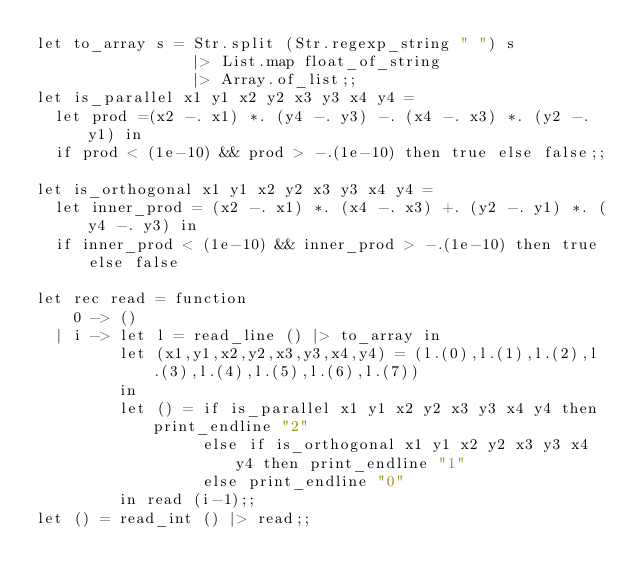Convert code to text. <code><loc_0><loc_0><loc_500><loc_500><_OCaml_>let to_array s = Str.split (Str.regexp_string " ") s
                 |> List.map float_of_string
                 |> Array.of_list;;
let is_parallel x1 y1 x2 y2 x3 y3 x4 y4 =
  let prod =(x2 -. x1) *. (y4 -. y3) -. (x4 -. x3) *. (y2 -. y1) in
  if prod < (1e-10) && prod > -.(1e-10) then true else false;;

let is_orthogonal x1 y1 x2 y2 x3 y3 x4 y4 =
  let inner_prod = (x2 -. x1) *. (x4 -. x3) +. (y2 -. y1) *. (y4 -. y3) in
  if inner_prod < (1e-10) && inner_prod > -.(1e-10) then true else false

let rec read = function
    0 -> ()
  | i -> let l = read_line () |> to_array in
         let (x1,y1,x2,y2,x3,y3,x4,y4) = (l.(0),l.(1),l.(2),l.(3),l.(4),l.(5),l.(6),l.(7))
         in
         let () = if is_parallel x1 y1 x2 y2 x3 y3 x4 y4 then print_endline "2"
                  else if is_orthogonal x1 y1 x2 y2 x3 y3 x4 y4 then print_endline "1"
                  else print_endline "0"
         in read (i-1);;
let () = read_int () |> read;;</code> 